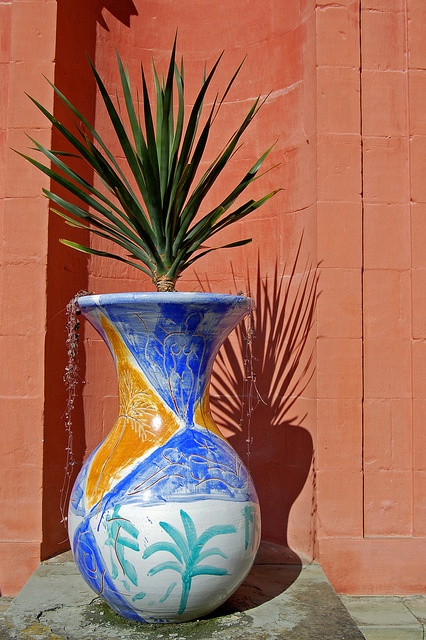Describe the objects in this image and their specific colors. I can see a vase in salmon, lightgray, darkgray, and gray tones in this image. 